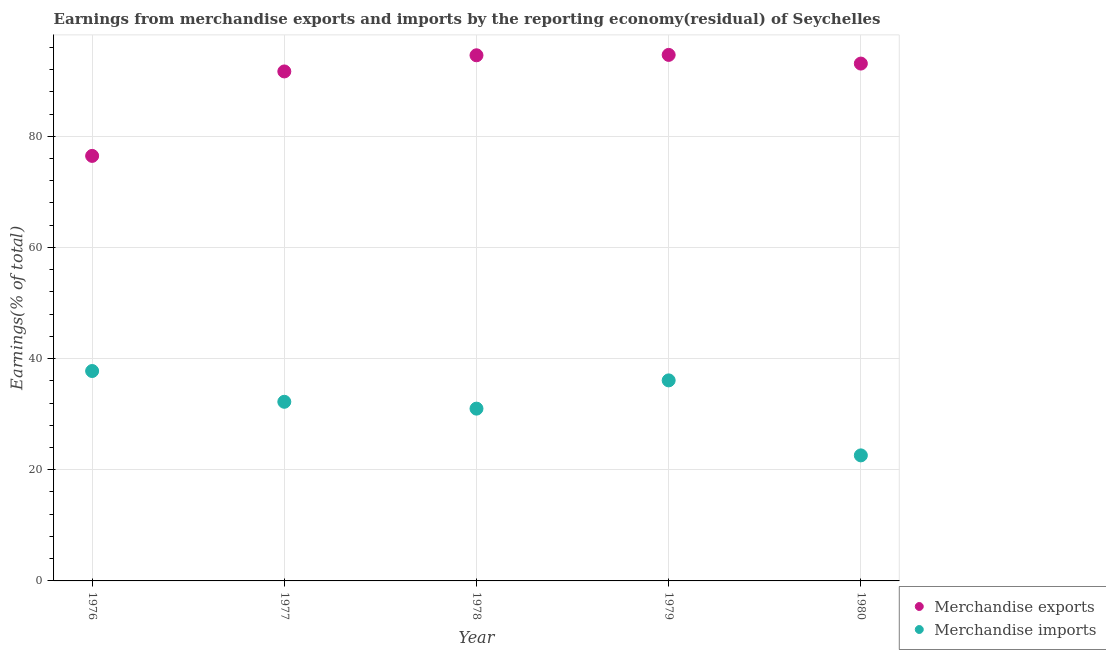How many different coloured dotlines are there?
Give a very brief answer. 2. What is the earnings from merchandise imports in 1978?
Give a very brief answer. 31. Across all years, what is the maximum earnings from merchandise exports?
Provide a succinct answer. 94.64. Across all years, what is the minimum earnings from merchandise imports?
Your answer should be very brief. 22.59. In which year was the earnings from merchandise exports maximum?
Offer a terse response. 1979. In which year was the earnings from merchandise exports minimum?
Give a very brief answer. 1976. What is the total earnings from merchandise exports in the graph?
Give a very brief answer. 450.44. What is the difference between the earnings from merchandise exports in 1978 and that in 1979?
Offer a very short reply. -0.07. What is the difference between the earnings from merchandise imports in 1979 and the earnings from merchandise exports in 1978?
Provide a short and direct response. -58.49. What is the average earnings from merchandise exports per year?
Provide a short and direct response. 90.09. In the year 1979, what is the difference between the earnings from merchandise imports and earnings from merchandise exports?
Offer a terse response. -58.56. In how many years, is the earnings from merchandise imports greater than 84 %?
Your answer should be very brief. 0. What is the ratio of the earnings from merchandise imports in 1977 to that in 1979?
Offer a very short reply. 0.89. Is the earnings from merchandise exports in 1976 less than that in 1977?
Offer a very short reply. Yes. Is the difference between the earnings from merchandise imports in 1976 and 1980 greater than the difference between the earnings from merchandise exports in 1976 and 1980?
Your response must be concise. Yes. What is the difference between the highest and the second highest earnings from merchandise imports?
Ensure brevity in your answer.  1.68. What is the difference between the highest and the lowest earnings from merchandise imports?
Your answer should be very brief. 15.18. Is the sum of the earnings from merchandise imports in 1977 and 1980 greater than the maximum earnings from merchandise exports across all years?
Offer a very short reply. No. Does the earnings from merchandise imports monotonically increase over the years?
Ensure brevity in your answer.  No. Is the earnings from merchandise exports strictly less than the earnings from merchandise imports over the years?
Offer a terse response. No. How many dotlines are there?
Give a very brief answer. 2. What is the difference between two consecutive major ticks on the Y-axis?
Make the answer very short. 20. Are the values on the major ticks of Y-axis written in scientific E-notation?
Offer a very short reply. No. Does the graph contain any zero values?
Offer a very short reply. No. Does the graph contain grids?
Offer a terse response. Yes. What is the title of the graph?
Offer a very short reply. Earnings from merchandise exports and imports by the reporting economy(residual) of Seychelles. What is the label or title of the Y-axis?
Offer a very short reply. Earnings(% of total). What is the Earnings(% of total) of Merchandise exports in 1976?
Your answer should be compact. 76.47. What is the Earnings(% of total) in Merchandise imports in 1976?
Your response must be concise. 37.77. What is the Earnings(% of total) in Merchandise exports in 1977?
Your answer should be very brief. 91.67. What is the Earnings(% of total) in Merchandise imports in 1977?
Offer a very short reply. 32.23. What is the Earnings(% of total) of Merchandise exports in 1978?
Give a very brief answer. 94.57. What is the Earnings(% of total) of Merchandise imports in 1978?
Offer a very short reply. 31. What is the Earnings(% of total) in Merchandise exports in 1979?
Offer a very short reply. 94.64. What is the Earnings(% of total) of Merchandise imports in 1979?
Give a very brief answer. 36.08. What is the Earnings(% of total) in Merchandise exports in 1980?
Give a very brief answer. 93.08. What is the Earnings(% of total) of Merchandise imports in 1980?
Your answer should be very brief. 22.59. Across all years, what is the maximum Earnings(% of total) in Merchandise exports?
Make the answer very short. 94.64. Across all years, what is the maximum Earnings(% of total) in Merchandise imports?
Offer a terse response. 37.77. Across all years, what is the minimum Earnings(% of total) of Merchandise exports?
Offer a very short reply. 76.47. Across all years, what is the minimum Earnings(% of total) in Merchandise imports?
Your answer should be compact. 22.59. What is the total Earnings(% of total) in Merchandise exports in the graph?
Make the answer very short. 450.44. What is the total Earnings(% of total) of Merchandise imports in the graph?
Your response must be concise. 159.66. What is the difference between the Earnings(% of total) in Merchandise exports in 1976 and that in 1977?
Your answer should be compact. -15.2. What is the difference between the Earnings(% of total) in Merchandise imports in 1976 and that in 1977?
Your answer should be very brief. 5.54. What is the difference between the Earnings(% of total) of Merchandise exports in 1976 and that in 1978?
Ensure brevity in your answer.  -18.1. What is the difference between the Earnings(% of total) of Merchandise imports in 1976 and that in 1978?
Offer a terse response. 6.77. What is the difference between the Earnings(% of total) in Merchandise exports in 1976 and that in 1979?
Make the answer very short. -18.17. What is the difference between the Earnings(% of total) of Merchandise imports in 1976 and that in 1979?
Ensure brevity in your answer.  1.68. What is the difference between the Earnings(% of total) in Merchandise exports in 1976 and that in 1980?
Provide a succinct answer. -16.61. What is the difference between the Earnings(% of total) of Merchandise imports in 1976 and that in 1980?
Your response must be concise. 15.18. What is the difference between the Earnings(% of total) in Merchandise exports in 1977 and that in 1978?
Your answer should be compact. -2.91. What is the difference between the Earnings(% of total) in Merchandise imports in 1977 and that in 1978?
Offer a terse response. 1.23. What is the difference between the Earnings(% of total) of Merchandise exports in 1977 and that in 1979?
Give a very brief answer. -2.98. What is the difference between the Earnings(% of total) of Merchandise imports in 1977 and that in 1979?
Keep it short and to the point. -3.85. What is the difference between the Earnings(% of total) in Merchandise exports in 1977 and that in 1980?
Ensure brevity in your answer.  -1.42. What is the difference between the Earnings(% of total) in Merchandise imports in 1977 and that in 1980?
Your answer should be very brief. 9.64. What is the difference between the Earnings(% of total) in Merchandise exports in 1978 and that in 1979?
Provide a short and direct response. -0.07. What is the difference between the Earnings(% of total) of Merchandise imports in 1978 and that in 1979?
Offer a terse response. -5.08. What is the difference between the Earnings(% of total) of Merchandise exports in 1978 and that in 1980?
Your answer should be compact. 1.49. What is the difference between the Earnings(% of total) in Merchandise imports in 1978 and that in 1980?
Give a very brief answer. 8.41. What is the difference between the Earnings(% of total) of Merchandise exports in 1979 and that in 1980?
Your answer should be compact. 1.56. What is the difference between the Earnings(% of total) in Merchandise imports in 1979 and that in 1980?
Give a very brief answer. 13.49. What is the difference between the Earnings(% of total) of Merchandise exports in 1976 and the Earnings(% of total) of Merchandise imports in 1977?
Keep it short and to the point. 44.24. What is the difference between the Earnings(% of total) of Merchandise exports in 1976 and the Earnings(% of total) of Merchandise imports in 1978?
Your answer should be very brief. 45.47. What is the difference between the Earnings(% of total) in Merchandise exports in 1976 and the Earnings(% of total) in Merchandise imports in 1979?
Your answer should be compact. 40.39. What is the difference between the Earnings(% of total) in Merchandise exports in 1976 and the Earnings(% of total) in Merchandise imports in 1980?
Ensure brevity in your answer.  53.88. What is the difference between the Earnings(% of total) of Merchandise exports in 1977 and the Earnings(% of total) of Merchandise imports in 1978?
Provide a short and direct response. 60.67. What is the difference between the Earnings(% of total) in Merchandise exports in 1977 and the Earnings(% of total) in Merchandise imports in 1979?
Your response must be concise. 55.59. What is the difference between the Earnings(% of total) of Merchandise exports in 1977 and the Earnings(% of total) of Merchandise imports in 1980?
Give a very brief answer. 69.08. What is the difference between the Earnings(% of total) of Merchandise exports in 1978 and the Earnings(% of total) of Merchandise imports in 1979?
Provide a succinct answer. 58.49. What is the difference between the Earnings(% of total) in Merchandise exports in 1978 and the Earnings(% of total) in Merchandise imports in 1980?
Your response must be concise. 71.99. What is the difference between the Earnings(% of total) of Merchandise exports in 1979 and the Earnings(% of total) of Merchandise imports in 1980?
Ensure brevity in your answer.  72.06. What is the average Earnings(% of total) in Merchandise exports per year?
Keep it short and to the point. 90.09. What is the average Earnings(% of total) of Merchandise imports per year?
Give a very brief answer. 31.93. In the year 1976, what is the difference between the Earnings(% of total) of Merchandise exports and Earnings(% of total) of Merchandise imports?
Give a very brief answer. 38.7. In the year 1977, what is the difference between the Earnings(% of total) of Merchandise exports and Earnings(% of total) of Merchandise imports?
Your answer should be very brief. 59.44. In the year 1978, what is the difference between the Earnings(% of total) of Merchandise exports and Earnings(% of total) of Merchandise imports?
Provide a succinct answer. 63.58. In the year 1979, what is the difference between the Earnings(% of total) in Merchandise exports and Earnings(% of total) in Merchandise imports?
Give a very brief answer. 58.56. In the year 1980, what is the difference between the Earnings(% of total) of Merchandise exports and Earnings(% of total) of Merchandise imports?
Keep it short and to the point. 70.49. What is the ratio of the Earnings(% of total) of Merchandise exports in 1976 to that in 1977?
Provide a short and direct response. 0.83. What is the ratio of the Earnings(% of total) of Merchandise imports in 1976 to that in 1977?
Keep it short and to the point. 1.17. What is the ratio of the Earnings(% of total) in Merchandise exports in 1976 to that in 1978?
Provide a short and direct response. 0.81. What is the ratio of the Earnings(% of total) in Merchandise imports in 1976 to that in 1978?
Your response must be concise. 1.22. What is the ratio of the Earnings(% of total) in Merchandise exports in 1976 to that in 1979?
Ensure brevity in your answer.  0.81. What is the ratio of the Earnings(% of total) of Merchandise imports in 1976 to that in 1979?
Ensure brevity in your answer.  1.05. What is the ratio of the Earnings(% of total) in Merchandise exports in 1976 to that in 1980?
Keep it short and to the point. 0.82. What is the ratio of the Earnings(% of total) in Merchandise imports in 1976 to that in 1980?
Keep it short and to the point. 1.67. What is the ratio of the Earnings(% of total) of Merchandise exports in 1977 to that in 1978?
Your answer should be compact. 0.97. What is the ratio of the Earnings(% of total) of Merchandise imports in 1977 to that in 1978?
Your answer should be compact. 1.04. What is the ratio of the Earnings(% of total) in Merchandise exports in 1977 to that in 1979?
Give a very brief answer. 0.97. What is the ratio of the Earnings(% of total) in Merchandise imports in 1977 to that in 1979?
Provide a succinct answer. 0.89. What is the ratio of the Earnings(% of total) of Merchandise imports in 1977 to that in 1980?
Give a very brief answer. 1.43. What is the ratio of the Earnings(% of total) of Merchandise exports in 1978 to that in 1979?
Ensure brevity in your answer.  1. What is the ratio of the Earnings(% of total) in Merchandise imports in 1978 to that in 1979?
Keep it short and to the point. 0.86. What is the ratio of the Earnings(% of total) in Merchandise exports in 1978 to that in 1980?
Your answer should be compact. 1.02. What is the ratio of the Earnings(% of total) in Merchandise imports in 1978 to that in 1980?
Ensure brevity in your answer.  1.37. What is the ratio of the Earnings(% of total) in Merchandise exports in 1979 to that in 1980?
Your answer should be very brief. 1.02. What is the ratio of the Earnings(% of total) of Merchandise imports in 1979 to that in 1980?
Provide a succinct answer. 1.6. What is the difference between the highest and the second highest Earnings(% of total) in Merchandise exports?
Your answer should be compact. 0.07. What is the difference between the highest and the second highest Earnings(% of total) of Merchandise imports?
Offer a very short reply. 1.68. What is the difference between the highest and the lowest Earnings(% of total) of Merchandise exports?
Ensure brevity in your answer.  18.17. What is the difference between the highest and the lowest Earnings(% of total) of Merchandise imports?
Your response must be concise. 15.18. 